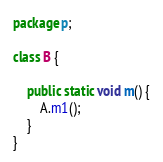Convert code to text. <code><loc_0><loc_0><loc_500><loc_500><_Java_>package p;

class B {

    public static void m() {
        A.m1();
    }
}
</code> 